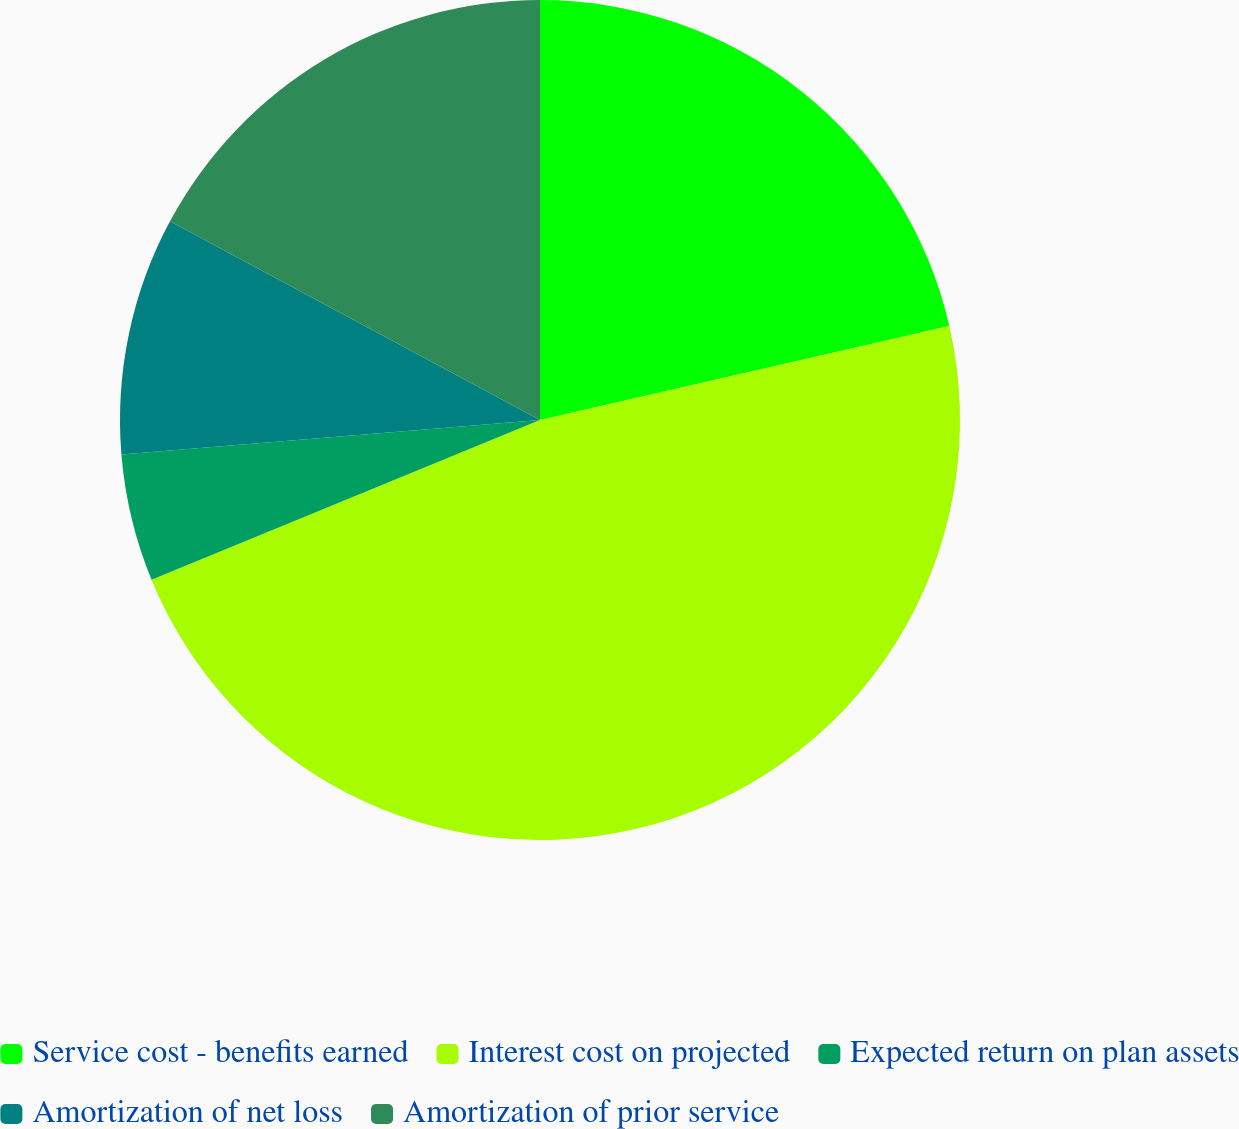Convert chart to OTSL. <chart><loc_0><loc_0><loc_500><loc_500><pie_chart><fcel>Service cost - benefits earned<fcel>Interest cost on projected<fcel>Expected return on plan assets<fcel>Amortization of net loss<fcel>Amortization of prior service<nl><fcel>21.41%<fcel>47.39%<fcel>4.9%<fcel>9.15%<fcel>17.16%<nl></chart> 